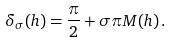Convert formula to latex. <formula><loc_0><loc_0><loc_500><loc_500>\delta _ { \sigma } ( h ) = \frac { \pi } { 2 } + \sigma \pi M ( h ) \, .</formula> 